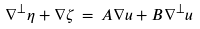Convert formula to latex. <formula><loc_0><loc_0><loc_500><loc_500>\nabla ^ { \perp } \eta + \nabla \zeta \, = \, A \nabla u + B \nabla ^ { \perp } u</formula> 